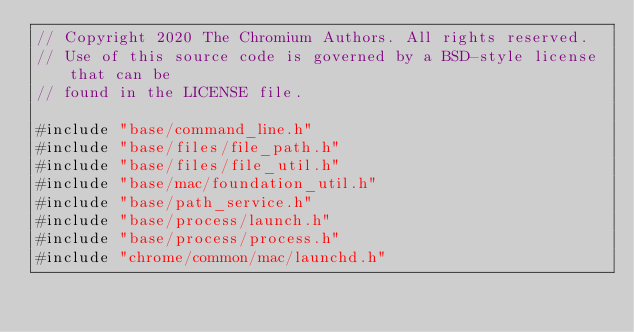<code> <loc_0><loc_0><loc_500><loc_500><_ObjectiveC_>// Copyright 2020 The Chromium Authors. All rights reserved.
// Use of this source code is governed by a BSD-style license that can be
// found in the LICENSE file.

#include "base/command_line.h"
#include "base/files/file_path.h"
#include "base/files/file_util.h"
#include "base/mac/foundation_util.h"
#include "base/path_service.h"
#include "base/process/launch.h"
#include "base/process/process.h"
#include "chrome/common/mac/launchd.h"</code> 